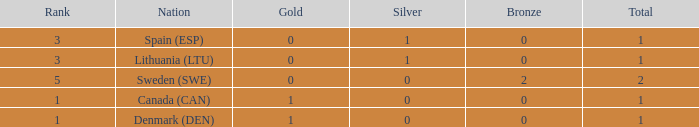What is the rank when there is 0 gold, the total is more than 1, and silver is more than 0? None. 